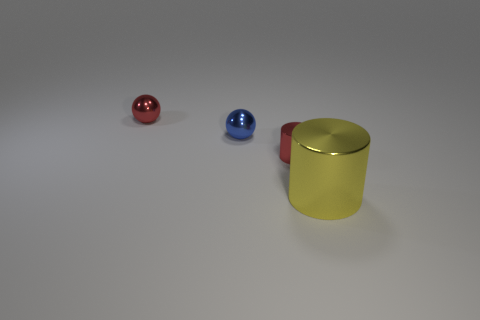Add 2 small blue shiny cubes. How many objects exist? 6 Add 3 tiny red rubber blocks. How many tiny red rubber blocks exist? 3 Subtract 1 red cylinders. How many objects are left? 3 Subtract all large shiny things. Subtract all big objects. How many objects are left? 2 Add 3 tiny spheres. How many tiny spheres are left? 5 